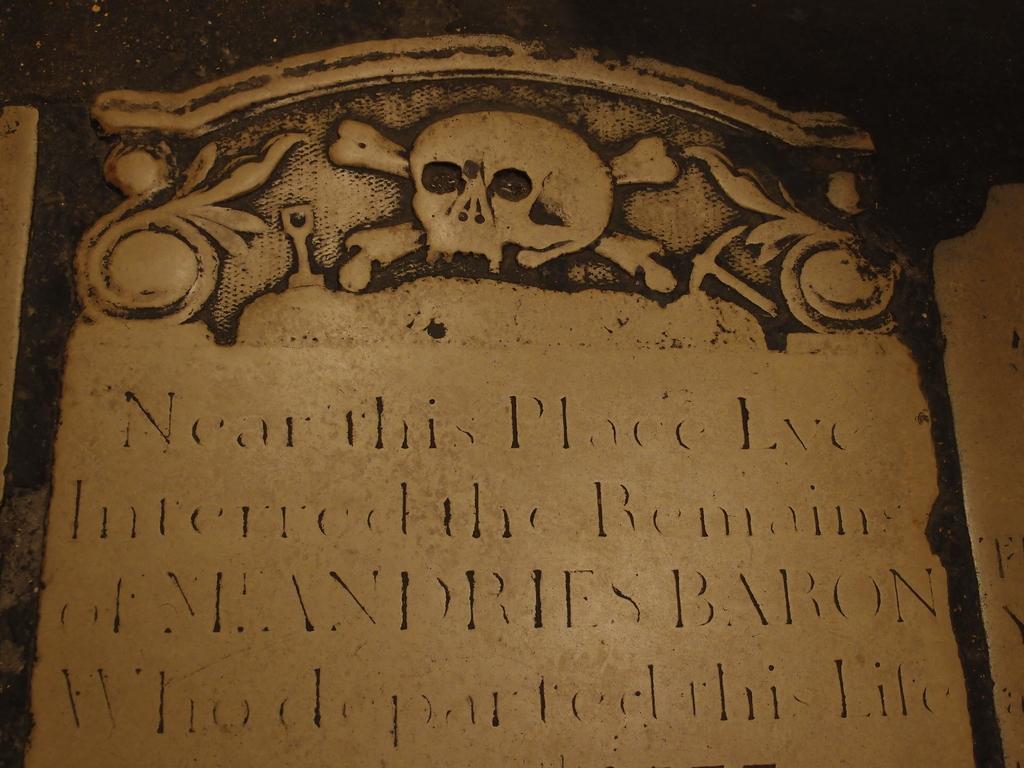In one or two sentences, can you explain what this image depicts? In this image I can see the stone carving which is in black and brown color. I can see something is written on it. 